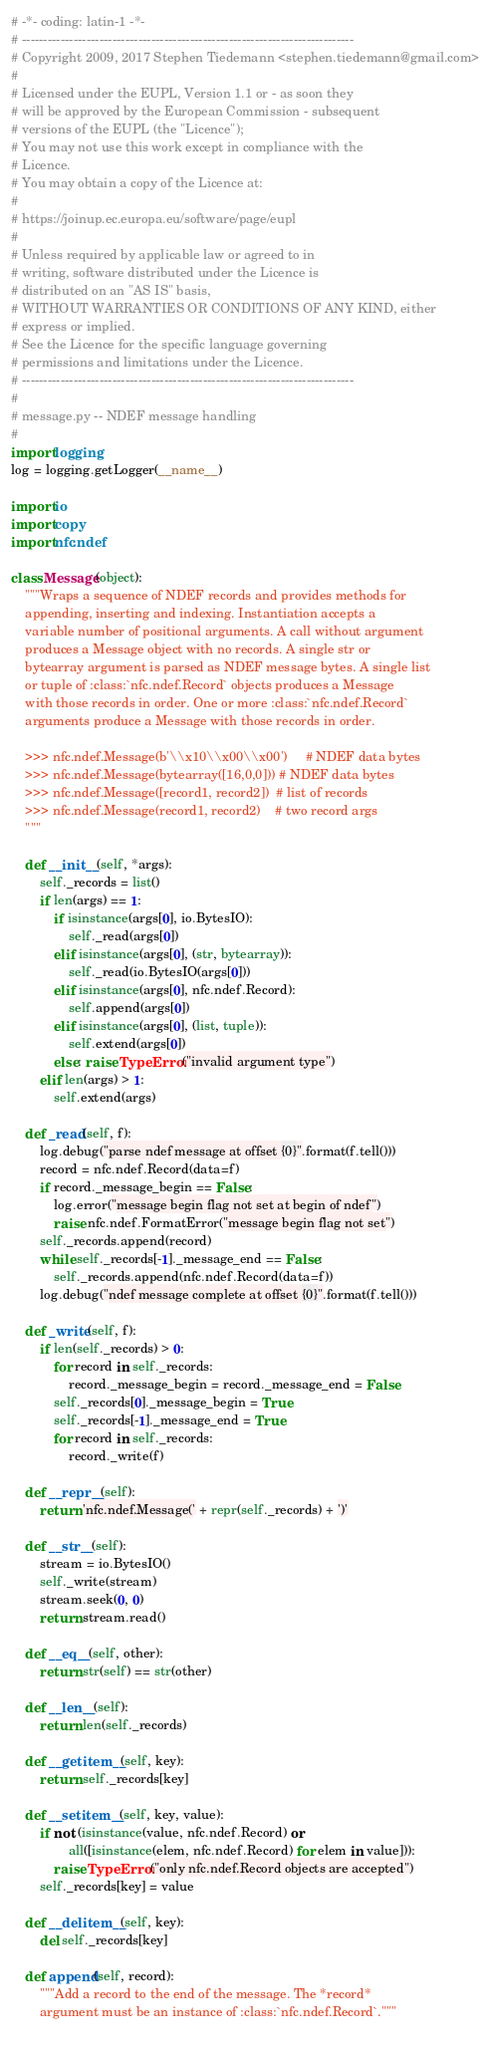<code> <loc_0><loc_0><loc_500><loc_500><_Python_># -*- coding: latin-1 -*-
# -----------------------------------------------------------------------------
# Copyright 2009, 2017 Stephen Tiedemann <stephen.tiedemann@gmail.com>
#
# Licensed under the EUPL, Version 1.1 or - as soon they 
# will be approved by the European Commission - subsequent
# versions of the EUPL (the "Licence");
# You may not use this work except in compliance with the
# Licence.
# You may obtain a copy of the Licence at:
#
# https://joinup.ec.europa.eu/software/page/eupl
#
# Unless required by applicable law or agreed to in
# writing, software distributed under the Licence is
# distributed on an "AS IS" basis,
# WITHOUT WARRANTIES OR CONDITIONS OF ANY KIND, either
# express or implied.
# See the Licence for the specific language governing
# permissions and limitations under the Licence.
# -----------------------------------------------------------------------------
#
# message.py -- NDEF message handling
#
import logging
log = logging.getLogger(__name__)

import io
import copy
import nfc.ndef

class Message(object):
    """Wraps a sequence of NDEF records and provides methods for
    appending, inserting and indexing. Instantiation accepts a
    variable number of positional arguments. A call without argument
    produces a Message object with no records. A single str or
    bytearray argument is parsed as NDEF message bytes. A single list
    or tuple of :class:`nfc.ndef.Record` objects produces a Message
    with those records in order. One or more :class:`nfc.ndef.Record`
    arguments produce a Message with those records in order.

    >>> nfc.ndef.Message(b'\\x10\\x00\\x00')     # NDEF data bytes
    >>> nfc.ndef.Message(bytearray([16,0,0])) # NDEF data bytes
    >>> nfc.ndef.Message([record1, record2])  # list of records
    >>> nfc.ndef.Message(record1, record2)    # two record args
    """
    
    def __init__(self, *args):
        self._records = list()
        if len(args) == 1:
            if isinstance(args[0], io.BytesIO):
                self._read(args[0])
            elif isinstance(args[0], (str, bytearray)):
                self._read(io.BytesIO(args[0]))
            elif isinstance(args[0], nfc.ndef.Record):
                self.append(args[0])
            elif isinstance(args[0], (list, tuple)):
                self.extend(args[0])
            else: raise TypeError("invalid argument type")
        elif len(args) > 1:
            self.extend(args)
        
    def _read(self, f):
        log.debug("parse ndef message at offset {0}".format(f.tell()))
        record = nfc.ndef.Record(data=f)
        if record._message_begin == False:
            log.error("message begin flag not set at begin of ndef")
            raise nfc.ndef.FormatError("message begin flag not set")
        self._records.append(record)
        while self._records[-1]._message_end == False:
            self._records.append(nfc.ndef.Record(data=f))
        log.debug("ndef message complete at offset {0}".format(f.tell()))

    def _write(self, f):
        if len(self._records) > 0:
            for record in self._records:
                record._message_begin = record._message_end = False
            self._records[0]._message_begin = True
            self._records[-1]._message_end = True
            for record in self._records:
                record._write(f)

    def __repr__(self):
        return 'nfc.ndef.Message(' + repr(self._records) + ')'
    
    def __str__(self):
        stream = io.BytesIO()
        self._write(stream)
        stream.seek(0, 0)
        return stream.read()

    def __eq__(self, other):
        return str(self) == str(other)
    
    def __len__(self):
        return len(self._records)

    def __getitem__(self, key):
        return self._records[key]

    def __setitem__(self, key, value):
        if not (isinstance(value, nfc.ndef.Record) or
                all([isinstance(elem, nfc.ndef.Record) for elem in value])):
            raise TypeError("only nfc.ndef.Record objects are accepted")
        self._records[key] = value

    def __delitem__(self, key):
        del self._records[key]

    def append(self, record):
        """Add a record to the end of the message. The *record*
        argument must be an instance of :class:`nfc.ndef.Record`."""
        </code> 